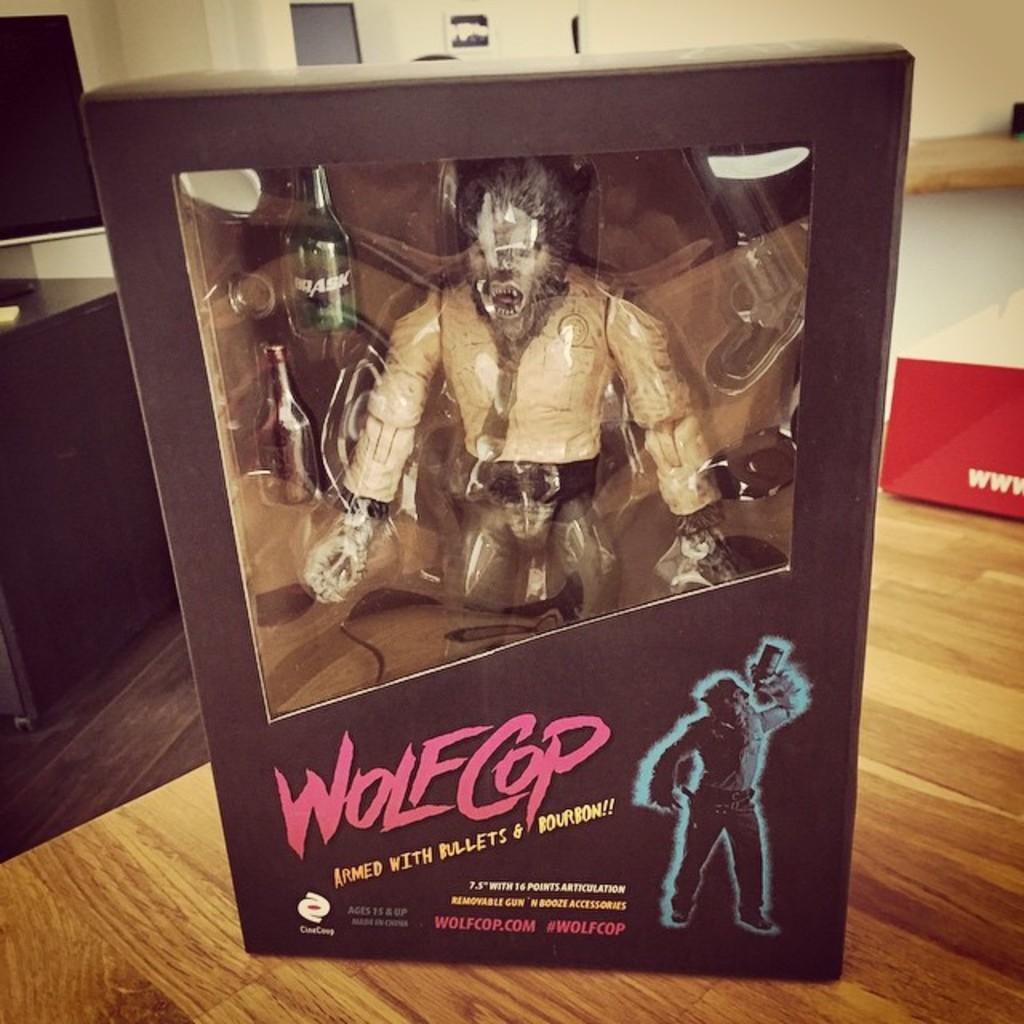Provide a one-sentence caption for the provided image. A figuring toy of a character named WolfCop. 